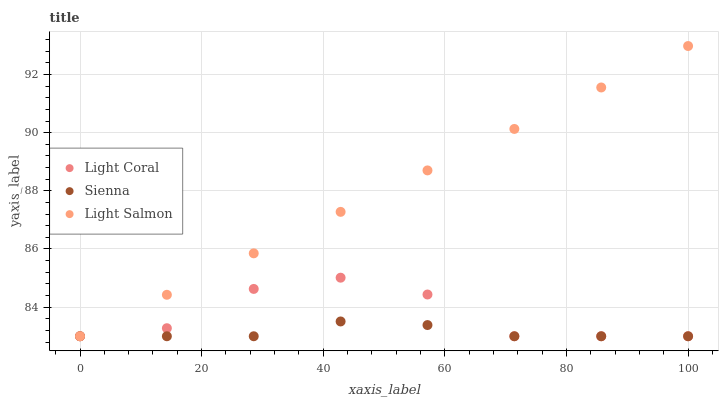Does Sienna have the minimum area under the curve?
Answer yes or no. Yes. Does Light Salmon have the maximum area under the curve?
Answer yes or no. Yes. Does Light Salmon have the minimum area under the curve?
Answer yes or no. No. Does Sienna have the maximum area under the curve?
Answer yes or no. No. Is Light Salmon the smoothest?
Answer yes or no. Yes. Is Light Coral the roughest?
Answer yes or no. Yes. Is Sienna the smoothest?
Answer yes or no. No. Is Sienna the roughest?
Answer yes or no. No. Does Light Coral have the lowest value?
Answer yes or no. Yes. Does Light Salmon have the highest value?
Answer yes or no. Yes. Does Sienna have the highest value?
Answer yes or no. No. Does Sienna intersect Light Coral?
Answer yes or no. Yes. Is Sienna less than Light Coral?
Answer yes or no. No. Is Sienna greater than Light Coral?
Answer yes or no. No. 